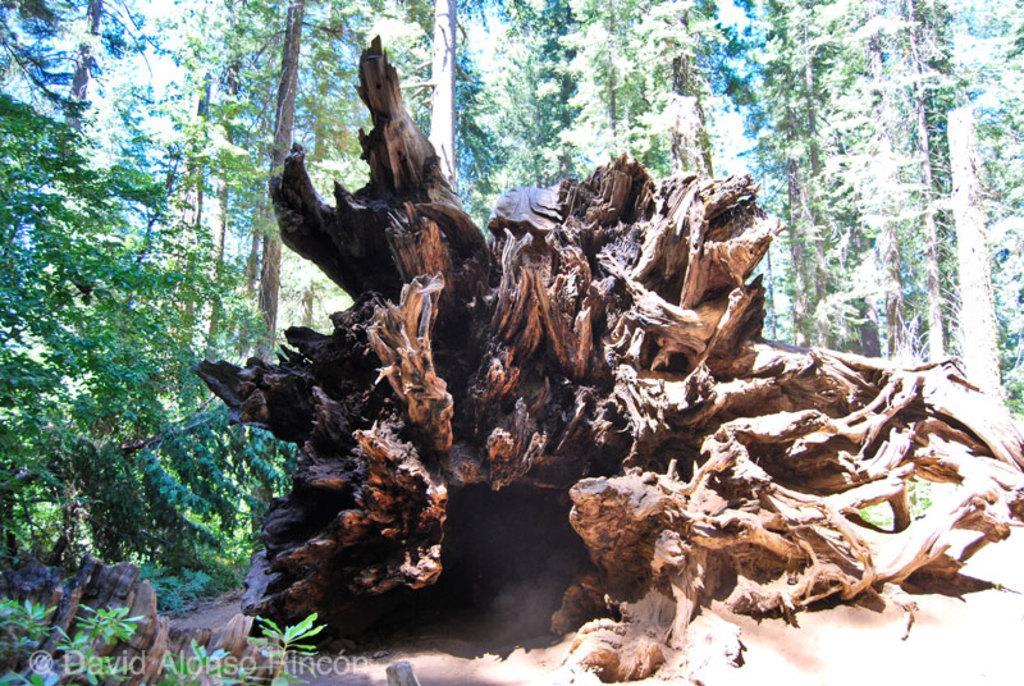Could you give a brief overview of what you see in this image? At the center of the image, we can see wood and in the background, there are trees. 